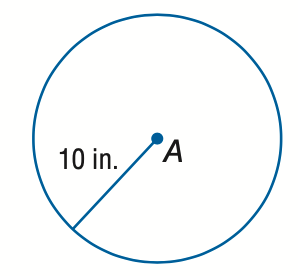Question: Find the circumference of \odot A.
Choices:
A. 10 \pi
B. 20 \pi
C. 50 \pi
D. 100 \pi
Answer with the letter. Answer: B 